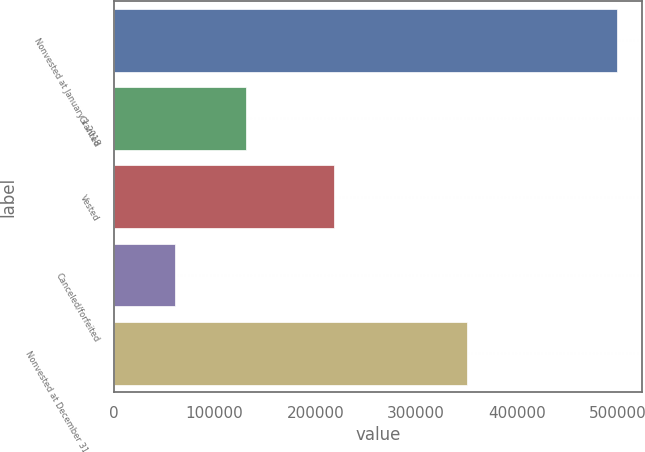Convert chart to OTSL. <chart><loc_0><loc_0><loc_500><loc_500><bar_chart><fcel>Nonvested at January 1 2018<fcel>Granted<fcel>Vested<fcel>Canceled/forfeited<fcel>Nonvested at December 31 2018<nl><fcel>498979<fcel>130715<fcel>218725<fcel>60291<fcel>350678<nl></chart> 